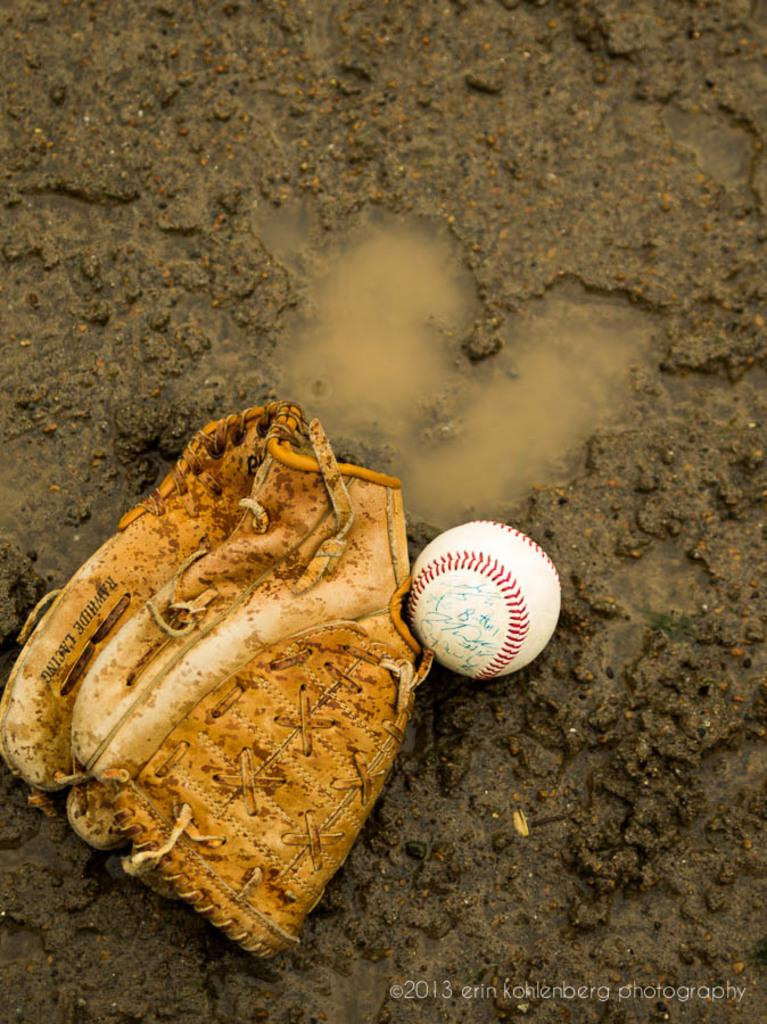What color is the glove that is visible in the image? The glove in the image is brown-colored. What object is white in color and present in the image? There is a white-colored ball in the image. What natural element is visible in the image? Water is visible in the image. Can you see a robin perched on the glove in the image? There is no robin present in the image; it only features a brown-colored glove and a white-colored ball. Is there a quilt visible in the image? There is no quilt present in the image. 